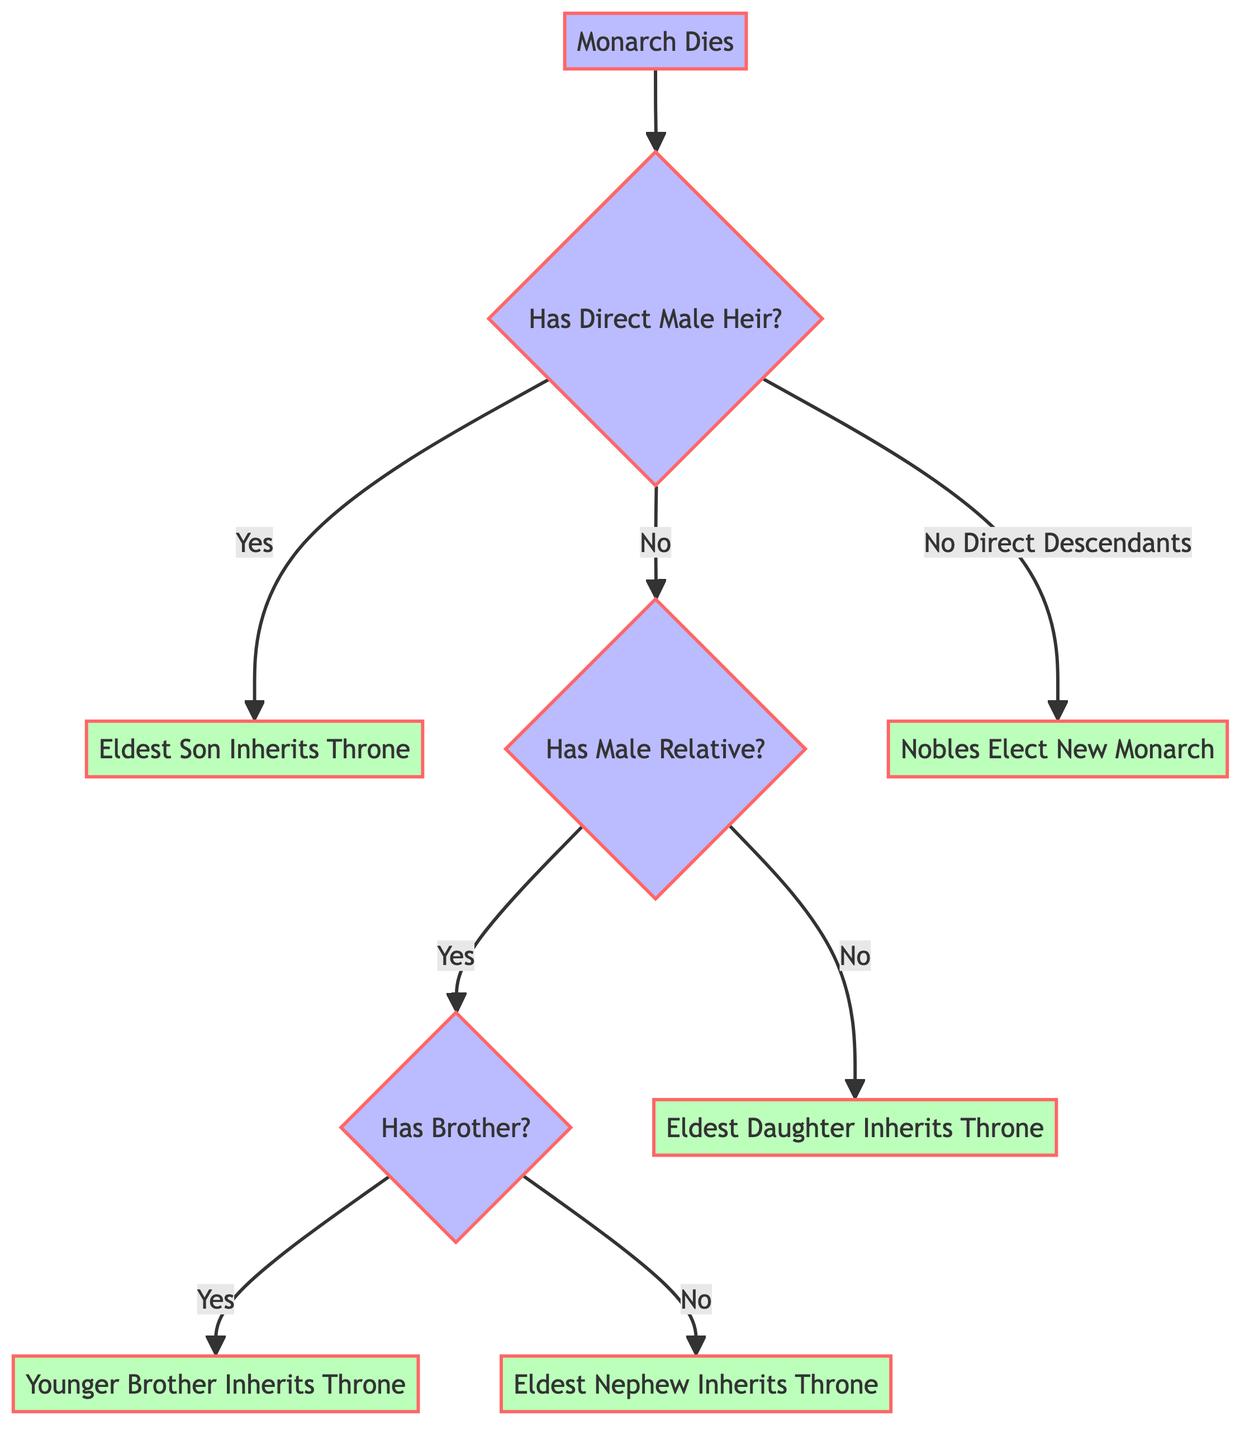What is the starting point of the decision tree? The diagram starts with the event where the "Monarch Dies," which is explicitly labeled as the starting point.
Answer: Monarch Dies How many main conditions follow the starting point? From "Monarch Dies," there are four main conditions that branch out: Has Direct Male Heir, No Direct Male Heir, No Male Relative, and No Direct Descendants. Therefore, the count is four.
Answer: 4 What happens if there is no male relative? If there is no male relative, the pathway leads to the condition where the "Eldest Daughter Inherits Throne," which is clearly stated in the diagram as the outcome in that scenario.
Answer: Eldest Daughter Inherits Throne What is the outcome when there is no direct male heir and no brother? When there is no direct male heir and no brother, the decision leads to the "Eldest Nephew Inherits Throne," showing that the nephew takes precedence in this case.
Answer: Eldest Nephew Inherits Throne If the monarch has a direct male heir, who inherits the throne? According to the diagram, if a direct male heir is present, the pathway leads to the outcome where the "Eldest Son Inherits Throne," indicating that the eldest son is the next in line for succession.
Answer: Eldest Son Inherits Throne How do nobles choose a new monarch when there are no direct descendants? In the scenario where there are no direct descendants, the decision tree shows that "Nobles Elect New Monarch," meaning that the existing noble families will select a new monarch based on their lineage or standing.
Answer: Nobles Elect New Monarch What type of heir inherits the throne if there are no direct male heirs or male relatives? The absence of direct male heirs and male relatives means that the diagram indicates the "Eldest Daughter Inherits Throne," implying that in the absence of male counterparts, the succession would pass to the eldest daughter.
Answer: Eldest Daughter Inherits Throne In total, how many pathways can be followed from the "No Direct Male Heir" condition? From the "No Direct Male Heir" condition, there are two pathways that can be followed based on the presence or absence of a brother: one leading to the "Younger Brother Inherits Throne" and the other to the "Eldest Nephew Inherits Throne." Thus, there are two distinct pathways.
Answer: 2 What is the specific condition that leads to a noble selection for a new monarch? The condition that results in noble selection for a new monarch occurs when there are "No Direct Descendants." This is a distinct pathway illustrated in the decision tree if no heirs exist.
Answer: No Direct Descendants 